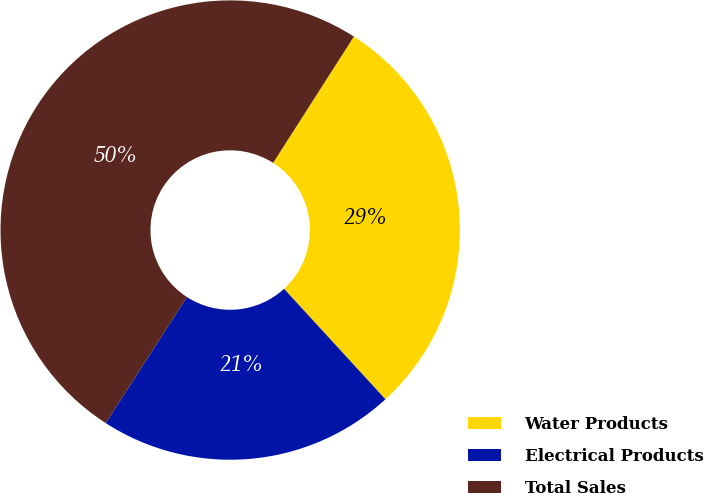<chart> <loc_0><loc_0><loc_500><loc_500><pie_chart><fcel>Water Products<fcel>Electrical Products<fcel>Total Sales<nl><fcel>29.13%<fcel>20.93%<fcel>49.94%<nl></chart> 